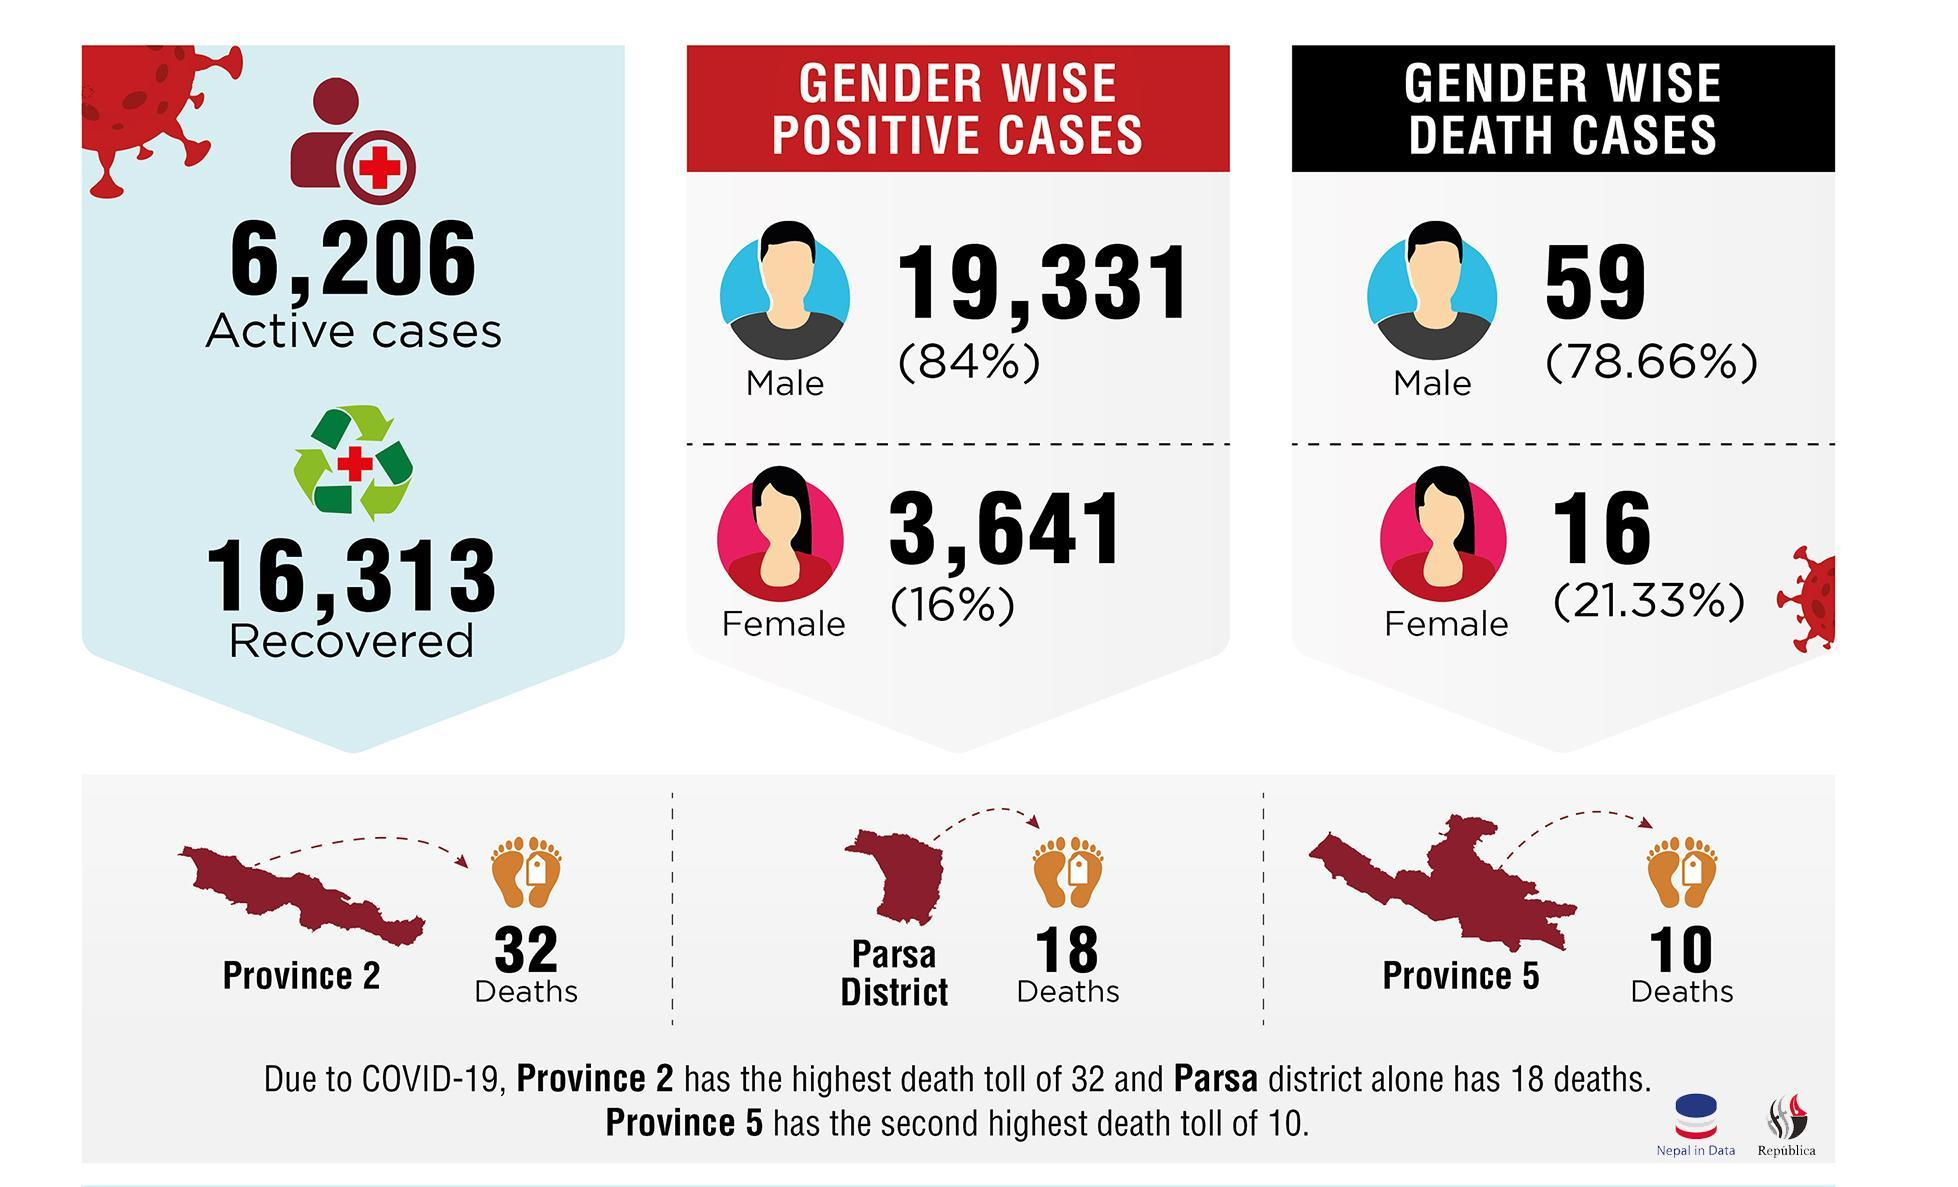By what percent is positive cases lower in females than males?
Answer the question with a short phrase. 68% Which area or region had 22 deaths more than Province 5? Province 2 By what percent is the death cases higher in males than females? 57.33% Which gender has the highest number of positive cases? Male 